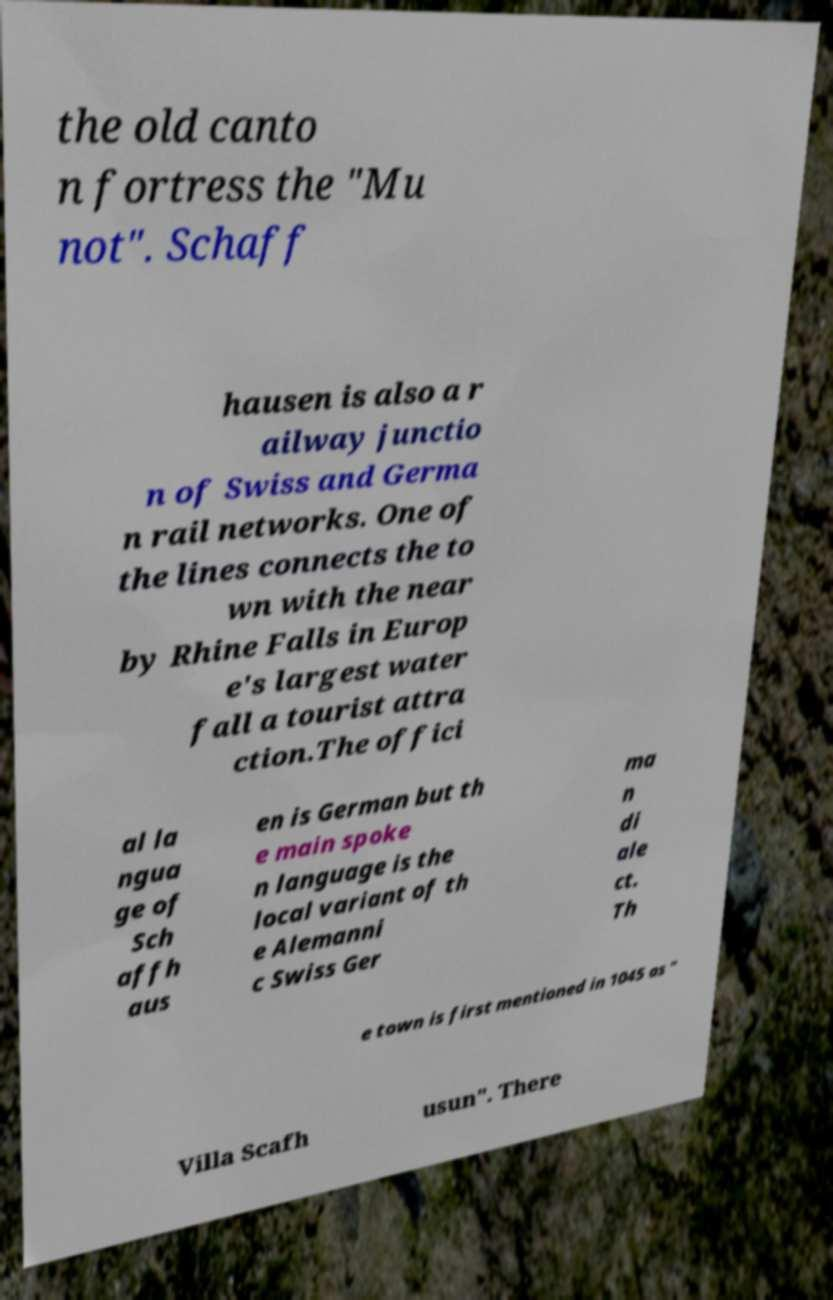Could you assist in decoding the text presented in this image and type it out clearly? the old canto n fortress the "Mu not". Schaff hausen is also a r ailway junctio n of Swiss and Germa n rail networks. One of the lines connects the to wn with the near by Rhine Falls in Europ e's largest water fall a tourist attra ction.The offici al la ngua ge of Sch affh aus en is German but th e main spoke n language is the local variant of th e Alemanni c Swiss Ger ma n di ale ct. Th e town is first mentioned in 1045 as " Villa Scafh usun". There 